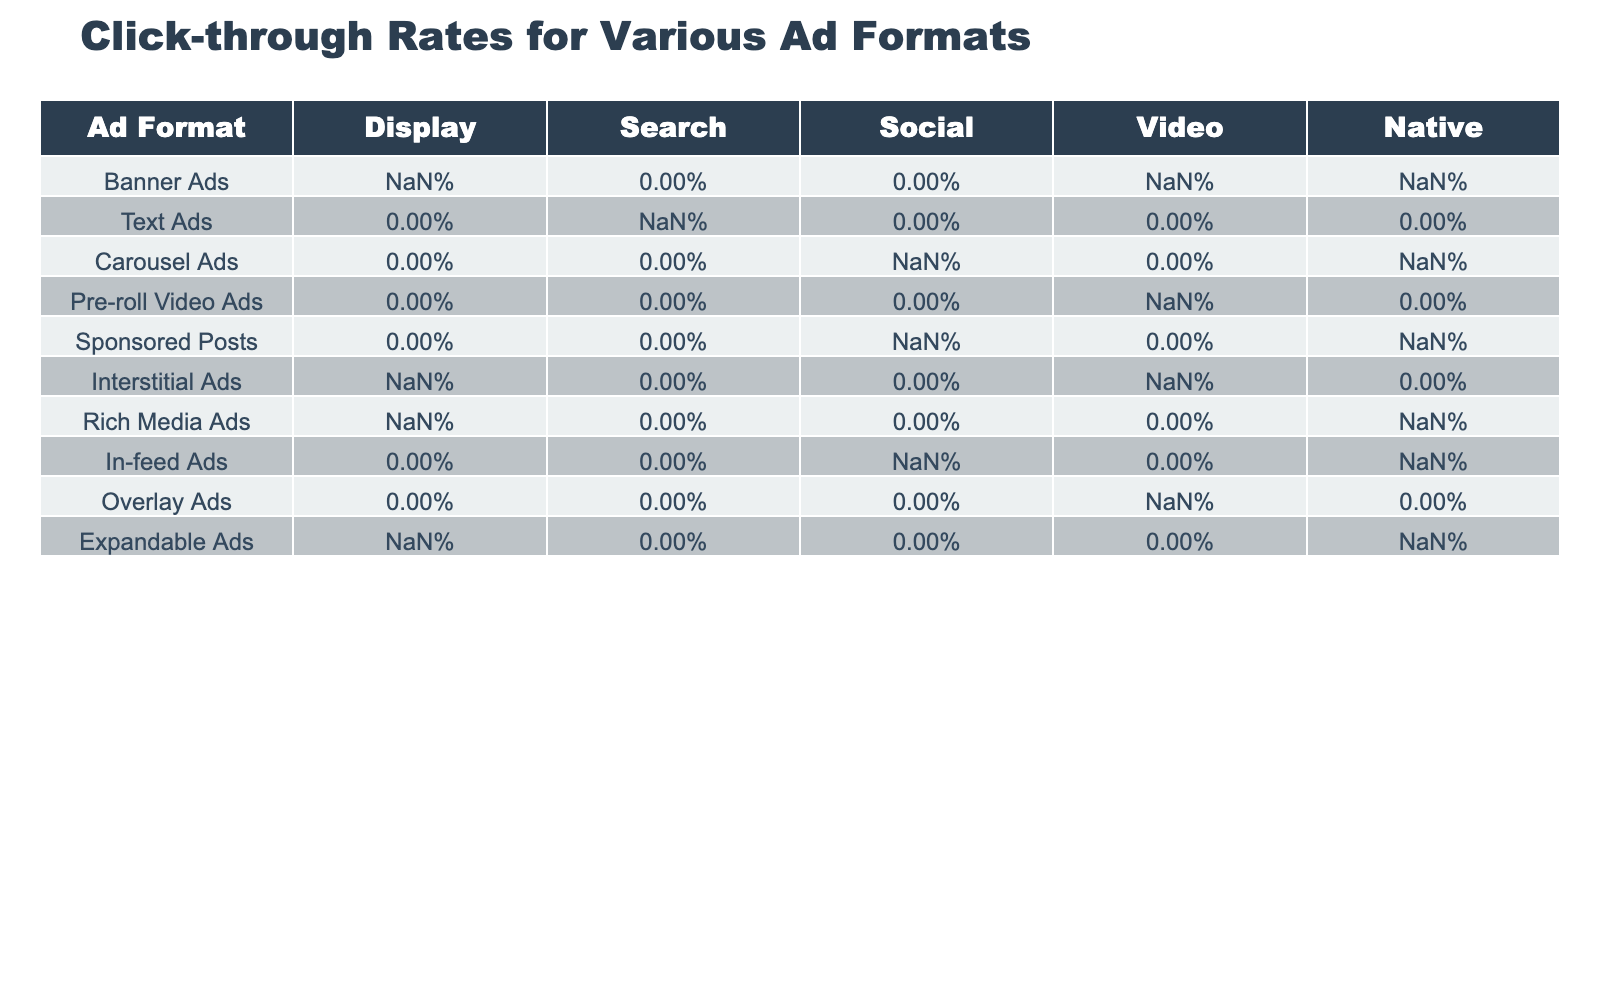What is the click-through rate for Banner Ads in the Search format? The table shows that Banner Ads do not have a value listed under the Search format, indicating that the click-through rate for this ad format in Search is not provided.
Answer: Not available Which ad format has the highest click-through rate in the Social format? Looking at the table, Sponsored Posts has the highest value of 2.21% in the Social format, compared to other formats listed.
Answer: Sponsored Posts What is the click-through rate for Interstitial Ads in the Video format? The table indicates that the click-through rate for Interstitial Ads in the Video format is 1.53%.
Answer: 1.53% Which ad format has a higher click-through rate in the Native format: Rich Media Ads or Expandable Ads? The click-through rate for Rich Media Ads in the Native format is 1.17%, while Expandable Ads show 1.05%, thus Rich Media Ads have a higher rate by comparison.
Answer: Rich Media Ads What is the average click-through rate for all ad formats in the Display column? The Display column has the following rates: 0.46%, 1.02%, 0.83%, and 0.72%. Adding these gives 3.03%, and dividing by the number of valid entries (4) results in an average of 0.7575%, which is approximately 0.76%.
Answer: 0.76% Is the click-through rate for Carousel Ads higher in the Video format compared to the In-feed Ads? The Carousel Ads have a click-through rate of 1.08% in the Video format, while In-feed Ads have 1.41%. Since 1.08% is less than 1.41%, Carousel Ads are lower than In-feed Ads in this respective format.
Answer: No How does the click-through rate for Native Ads compare to the one for Video Ads across all formats? The Native format includes rates of 0.80%, 1.35%, 2.21%, and 1.76% for various ad types, while Video Ads feature rates of 1.84% and 1.29% for Pre-roll and Overlay, respectively. The highest in Native is 2.21%, which is higher than the top value of 1.84% in Video.
Answer: Native Ads have a higher maximum rate What percentage difference exists between the click-through rates of Sponsored Posts in Social and Interstitial Ads in Video? Sponsored Posts have a rate of 2.21% in the Social format, and Interstitial Ads have a rate of 1.53% in Video. The difference is 2.21% - 1.53% = 0.68%, which as a percentage of the lower value (1.53%) is (0.68/1.53)*100 ≈ 44.44%.
Answer: Approximately 44.44% 